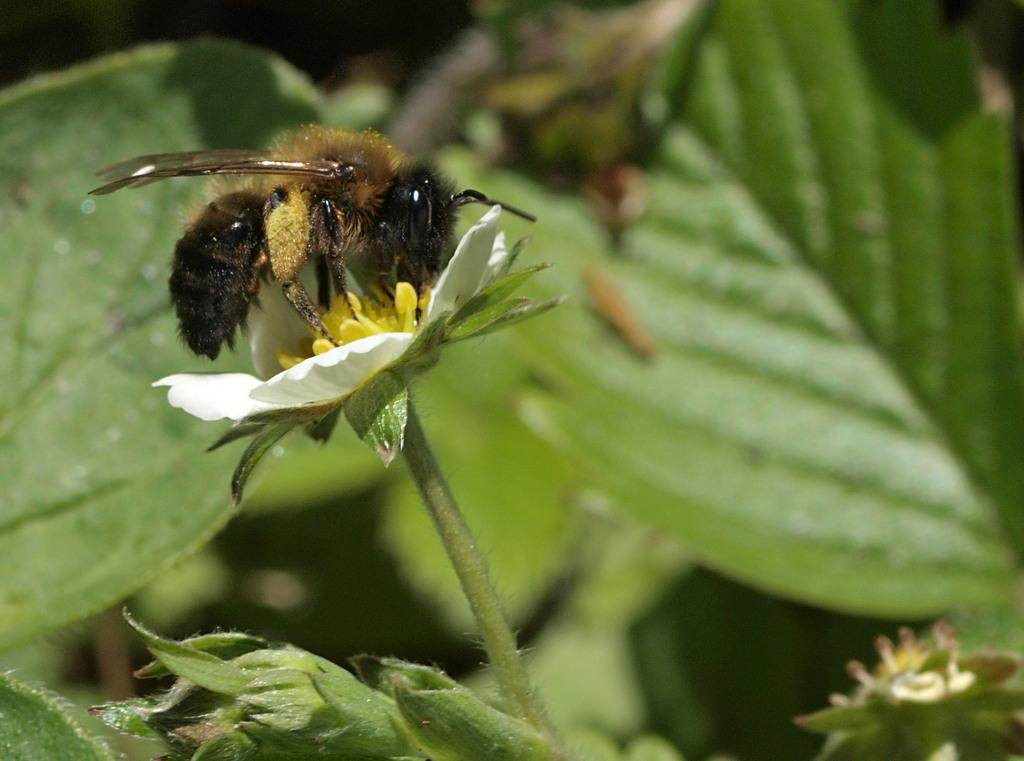What is on the flower in the image? There is an insect on a flower in the image. What can be seen in the background of the image? There are leaves visible in the background of the image. What is the purpose of the railway in the image? There is no railway present in the image; it features an insect on a flower and leaves in the background. Are there any dinosaurs visible in the image? There are no dinosaurs present in the image. 